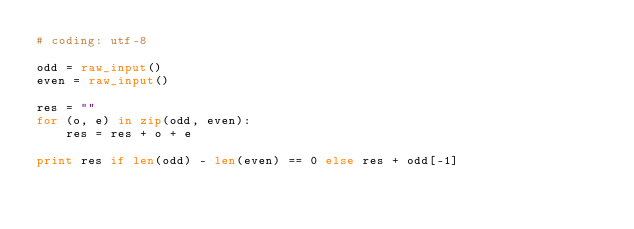<code> <loc_0><loc_0><loc_500><loc_500><_Python_># coding: utf-8

odd = raw_input()
even = raw_input()

res = ""
for (o, e) in zip(odd, even):
    res = res + o + e

print res if len(odd) - len(even) == 0 else res + odd[-1]
</code> 